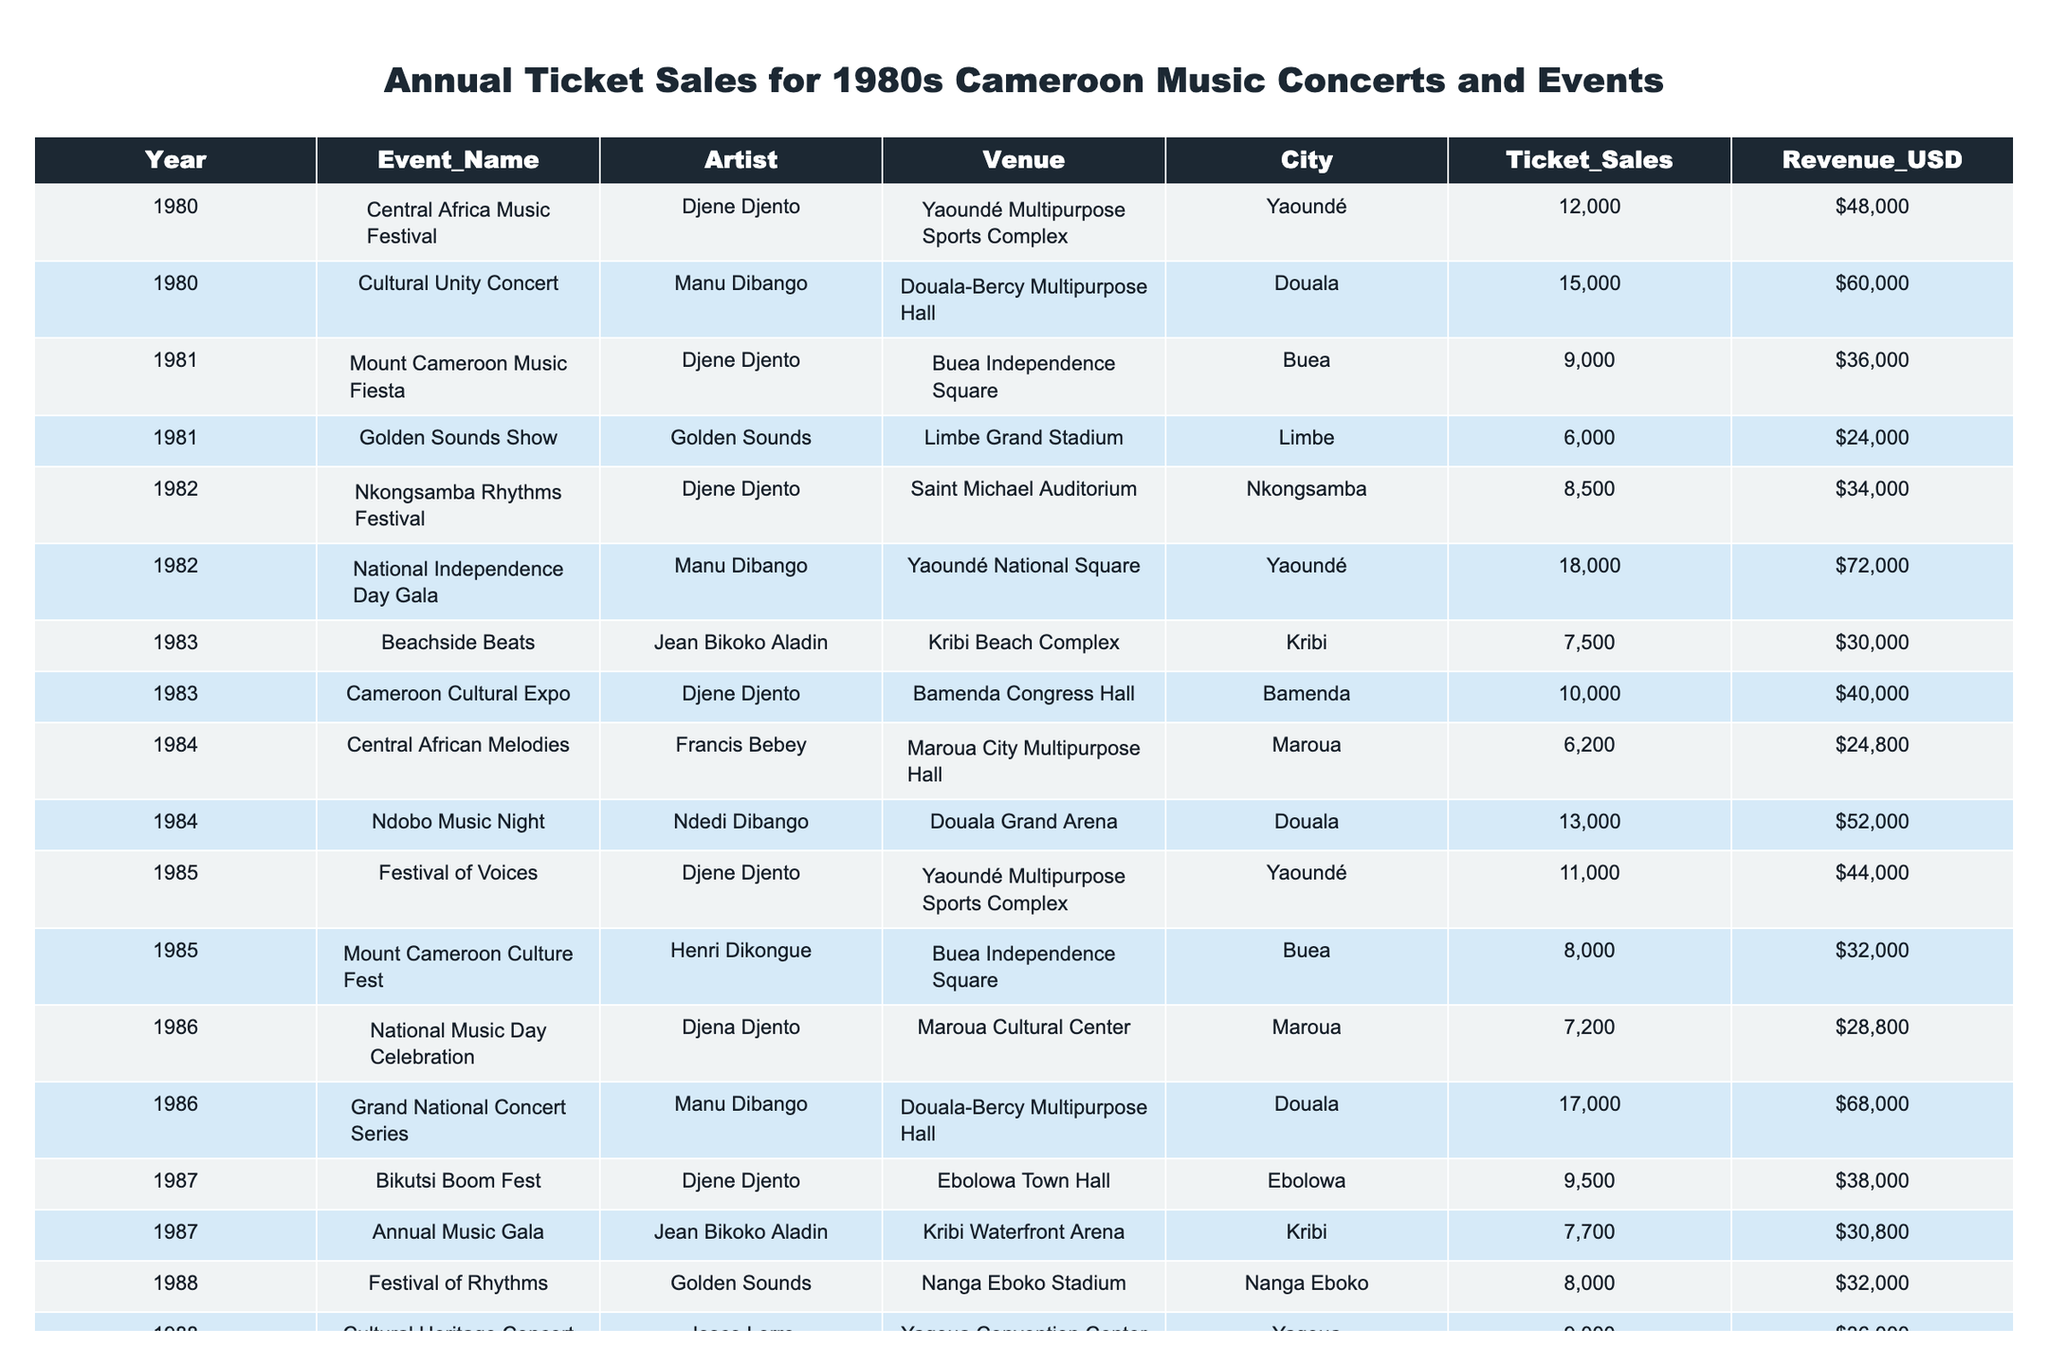What was the total ticket sales for Djene Djento concerts in 1980? The data shows two events featuring Djene Djento in 1980: the Central Africa Music Festival with 12,000 ticket sales and the Mount Cameroon Music Fiesta with 9,000 ticket sales. Adding these gives 12,000 + 9,000 = 21,000 ticket sales.
Answer: 21,000 Which city hosted the highest revenue event in 1982? The table shows two events in 1982: the Nkongsamba Rhythms Festival in Nkongsamba with revenue of $34,000 and the National Independence Day Gala in Yaoundé with revenue of $72,000. Yaoundé has the highest revenue with $72,000.
Answer: Yaoundé Did Douala host more events than Yaoundé in 1986? In 1986, Douala hosted one event (the Grand National Concert Series) and Yaoundé hosted one event (the National Music Day Celebration). Both cities hosted the same number of events, hence the answer is no.
Answer: No What was the average ticket sales for all events in 1987? In 1987, two events are listed: the Bikutsi Boom Fest with 9,500 ticket sales and the Annual Music Gala with 7,700 ticket sales. The total is 9,500 + 7,700 = 17,200. Dividing by 2 gives an average of 17,200 / 2 = 8,600.
Answer: 8,600 Was the ticket sale revenue from the Cultural Unity Concert greater than $50,000? The Cultural Unity Concert had a revenue of $60,000 according to the table, which is greater than $50,000.
Answer: Yes Calculate the total revenue generated from events in Limbe. The events in Limbe are the Golden Sounds Show with $24,000 revenue and the End of Year Music Bash with $27,200 revenue. Adding these revenues gives $24,000 + $27,200 = $51,200.
Answer: $51,200 How many events featuring Manu Dibango had ticket sales of more than 15,000? There are two events featuring Manu Dibango: the Cultural Unity Concert with 15,000 ticket sales and the Grand National Concert Series with 17,000 ticket sales. Only one event (the Grand National Concert Series) has ticket sales over 15,000.
Answer: 1 What was the total number of ticket sales across all events in 1989? In 1989, there were two events: the Cameroon Music Extravaganza with 12,500 ticket sales and the End of Year Music Bash with 6,800 ticket sales. Adding these gives 12,500 + 6,800 = 19,300 total ticket sales.
Answer: 19,300 